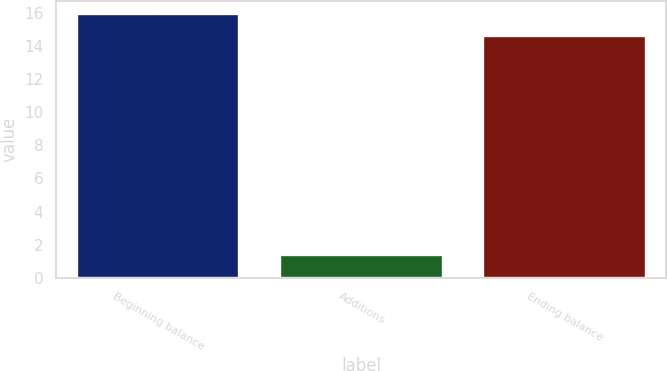Convert chart. <chart><loc_0><loc_0><loc_500><loc_500><bar_chart><fcel>Beginning balance<fcel>Additions<fcel>Ending balance<nl><fcel>15.95<fcel>1.4<fcel>14.6<nl></chart> 